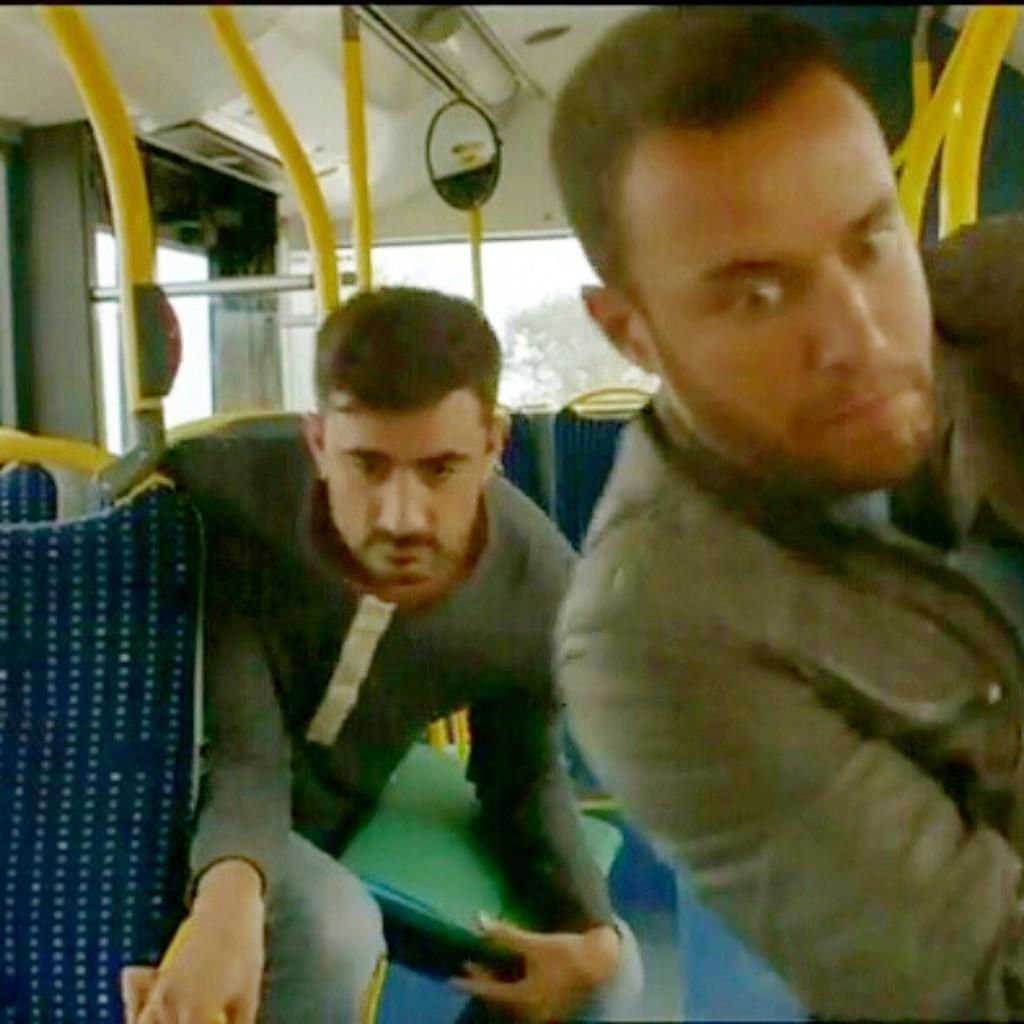Could you give a brief overview of what you see in this image? This picture seems to be clicked inside the vehicle. In the center we can see the group of people sitting on the seats and we can see the seats of the vehicle, metal rods and some other objects. At the top there is a roof of the vehicle. In the background we can see the window and through the window we can see the outside view. 